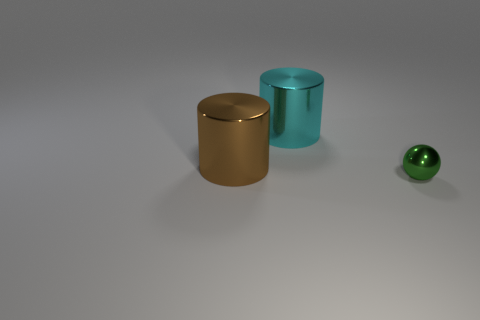What is the size of the thing that is behind the large metallic thing that is in front of the big cyan metallic thing?
Your response must be concise. Large. Is there anything else that is the same size as the green ball?
Ensure brevity in your answer.  No. Is the number of big cyan objects behind the green sphere greater than the number of big cyan shiny cylinders on the left side of the brown metal object?
Provide a succinct answer. Yes. How big is the brown object?
Your response must be concise. Large. There is a object that is in front of the brown metallic cylinder; what shape is it?
Your response must be concise. Sphere. Do the big brown metallic thing and the cyan thing have the same shape?
Keep it short and to the point. Yes. Are there the same number of small green metallic things behind the large cyan shiny cylinder and big brown metal balls?
Offer a very short reply. Yes. There is a tiny shiny thing; what shape is it?
Offer a terse response. Sphere. Are there any other things that are the same color as the tiny metallic sphere?
Ensure brevity in your answer.  No. There is a metal object that is in front of the brown thing; is it the same size as the cylinder that is to the left of the big cyan metal thing?
Keep it short and to the point. No. 